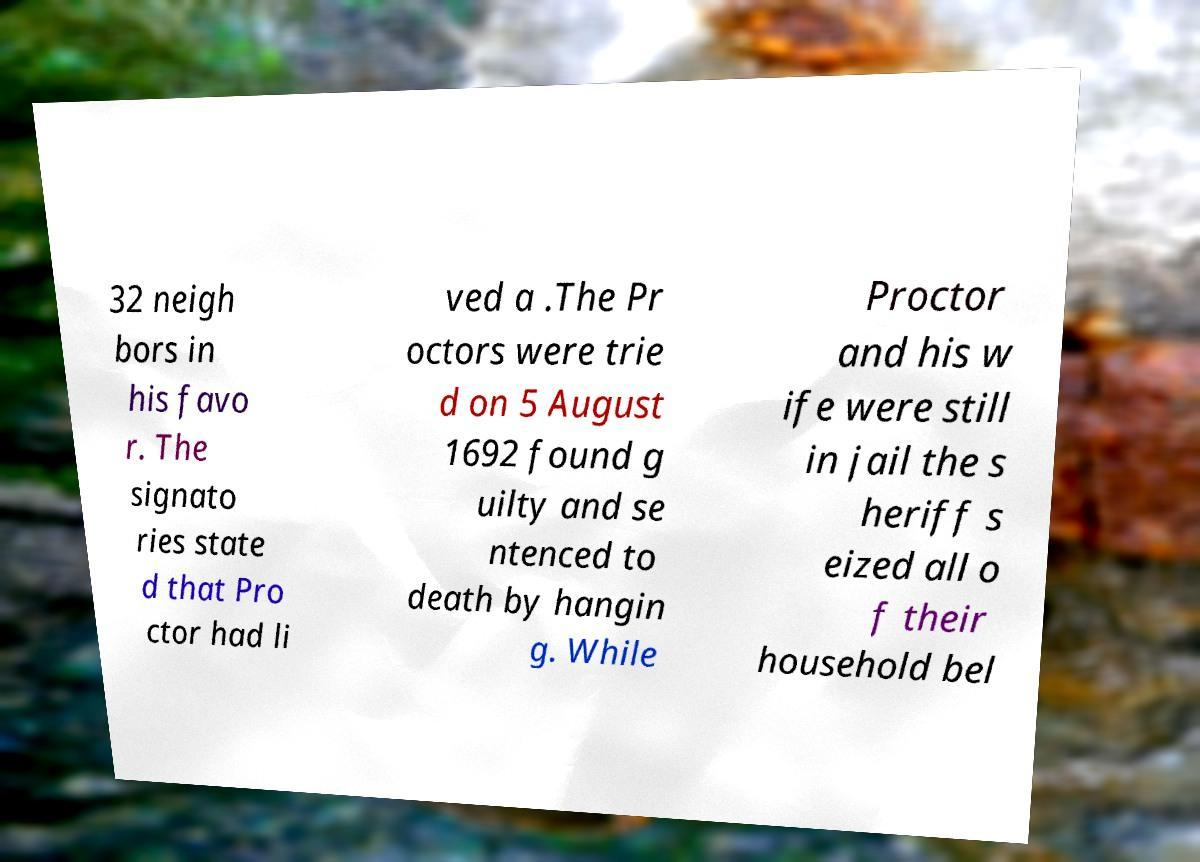Can you read and provide the text displayed in the image?This photo seems to have some interesting text. Can you extract and type it out for me? 32 neigh bors in his favo r. The signato ries state d that Pro ctor had li ved a .The Pr octors were trie d on 5 August 1692 found g uilty and se ntenced to death by hangin g. While Proctor and his w ife were still in jail the s heriff s eized all o f their household bel 